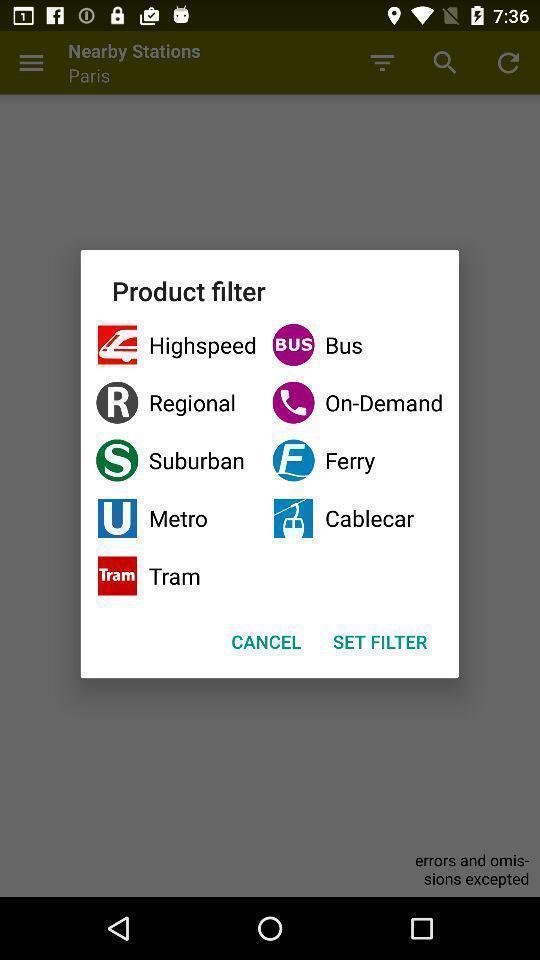Provide a textual representation of this image. Pop-up showing menu of commute options of travel app. 